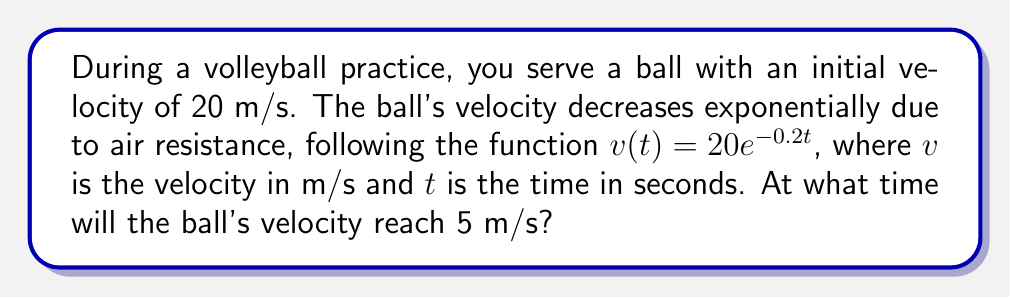Teach me how to tackle this problem. To solve this problem, we need to use the given exponential decay function and find the time when the velocity equals 5 m/s. Let's approach this step-by-step:

1) We're given the function: $v(t) = 20e^{-0.2t}$

2) We want to find $t$ when $v(t) = 5$. So, we can set up the equation:

   $5 = 20e^{-0.2t}$

3) Divide both sides by 20:

   $\frac{5}{20} = e^{-0.2t}$

4) Simplify:

   $0.25 = e^{-0.2t}$

5) Take the natural logarithm of both sides:

   $\ln(0.25) = \ln(e^{-0.2t})$

6) Simplify the right side using the properties of logarithms:

   $\ln(0.25) = -0.2t$

7) Solve for $t$:

   $t = -\frac{\ln(0.25)}{0.2}$

8) Calculate the value:

   $t = -\frac{-1.3862943611}{0.2} \approx 6.93$ seconds

Therefore, the ball's velocity will reach 5 m/s after approximately 6.93 seconds.
Answer: 6.93 seconds 